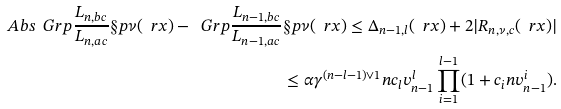Convert formula to latex. <formula><loc_0><loc_0><loc_500><loc_500>\ A b s { \ G r p { \frac { L _ { n , b c } } { L _ { n , a c } } } \S p \nu ( \ r x ) - \ G r p { \frac { L _ { n - 1 , b c } } { L _ { n - 1 , a c } } } \S p \nu ( \ r x ) } \leq \Delta _ { n - 1 , l } ( \ r x ) + 2 | R _ { n , \nu , c } ( \ r x ) | \\ \leq \alpha \gamma ^ { ( n - l - 1 ) \vee 1 } n c _ { l } v _ { n - 1 } ^ { l } \prod _ { i = 1 } ^ { l - 1 } ( 1 + c _ { i } n v _ { n - 1 } ^ { i } ) .</formula> 